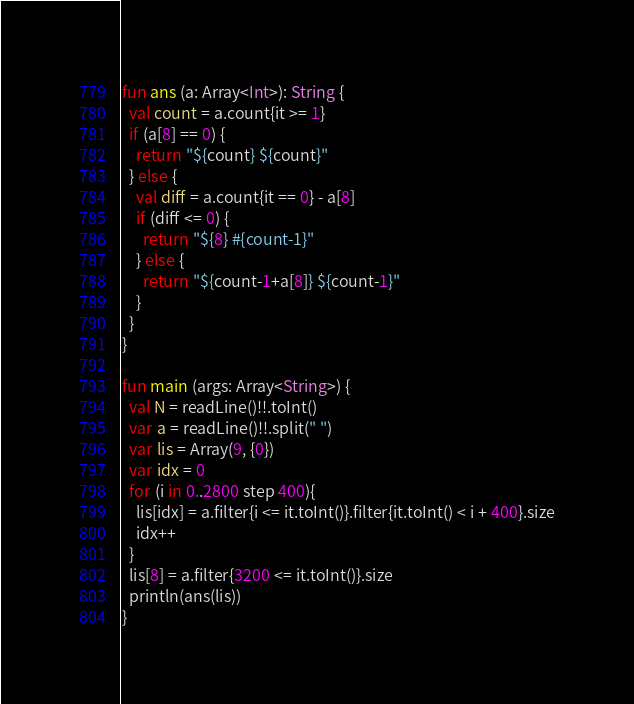<code> <loc_0><loc_0><loc_500><loc_500><_Kotlin_>fun ans (a: Array<Int>): String {
  val count = a.count{it >= 1}
  if (a[8] == 0) {
    return "${count} ${count}"
  } else {
    val diff = a.count{it == 0} - a[8]
    if (diff <= 0) {
      return "${8} #{count-1}"
    } else {
      return "${count-1+a[8]} ${count-1}"
    }
  }
}

fun main (args: Array<String>) {
  val N = readLine()!!.toInt()
  var a = readLine()!!.split(" ")
  var lis = Array(9, {0})
  var idx = 0
  for (i in 0..2800 step 400){
    lis[idx] = a.filter{i <= it.toInt()}.filter{it.toInt() < i + 400}.size
    idx++
  }
  lis[8] = a.filter{3200 <= it.toInt()}.size
  println(ans(lis))
}
</code> 